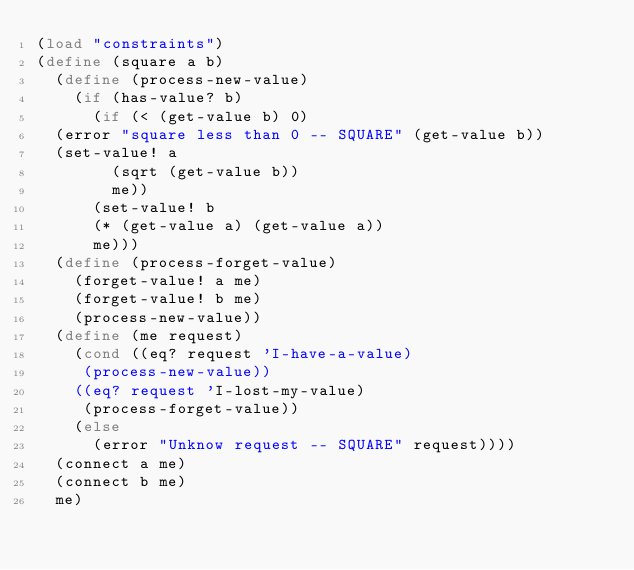<code> <loc_0><loc_0><loc_500><loc_500><_Scheme_>(load "constraints")
(define (square a b)
  (define (process-new-value)
    (if (has-value? b)
      (if (< (get-value b) 0)
	(error "square less than 0 -- SQUARE" (get-value b))
	(set-value! a
		    (sqrt (get-value b))
		    me))
      (set-value! b
		  (* (get-value a) (get-value a))
		  me)))
  (define (process-forget-value)
    (forget-value! a me)
    (forget-value! b me)
    (process-new-value))
  (define (me request)
    (cond ((eq? request 'I-have-a-value)
	   (process-new-value))
	  ((eq? request 'I-lost-my-value)
	   (process-forget-value))
	  (else
	    (error "Unknow request -- SQUARE" request))))
  (connect a me)
  (connect b me)
  me)
</code> 